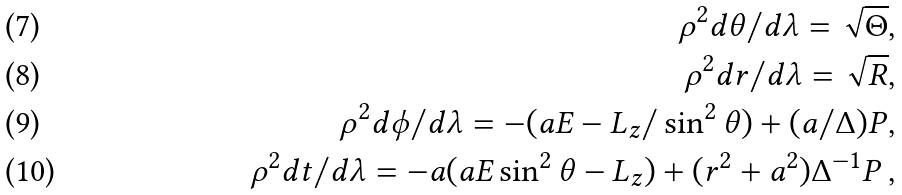<formula> <loc_0><loc_0><loc_500><loc_500>\rho ^ { 2 } d \theta / d \lambda = \sqrt { \Theta } , \\ \rho ^ { 2 } d r / d \lambda = \sqrt { R } , \\ \rho ^ { 2 } d \phi / d \lambda = - ( a E - L _ { z } / \sin ^ { 2 } { \theta } ) + ( a / \Delta ) P , \\ \rho ^ { 2 } d t / d \lambda = - a ( a E \sin ^ { 2 } { \theta } - L _ { z } ) + ( r ^ { 2 } + a ^ { 2 } ) \Delta ^ { - 1 } P \, ,</formula> 